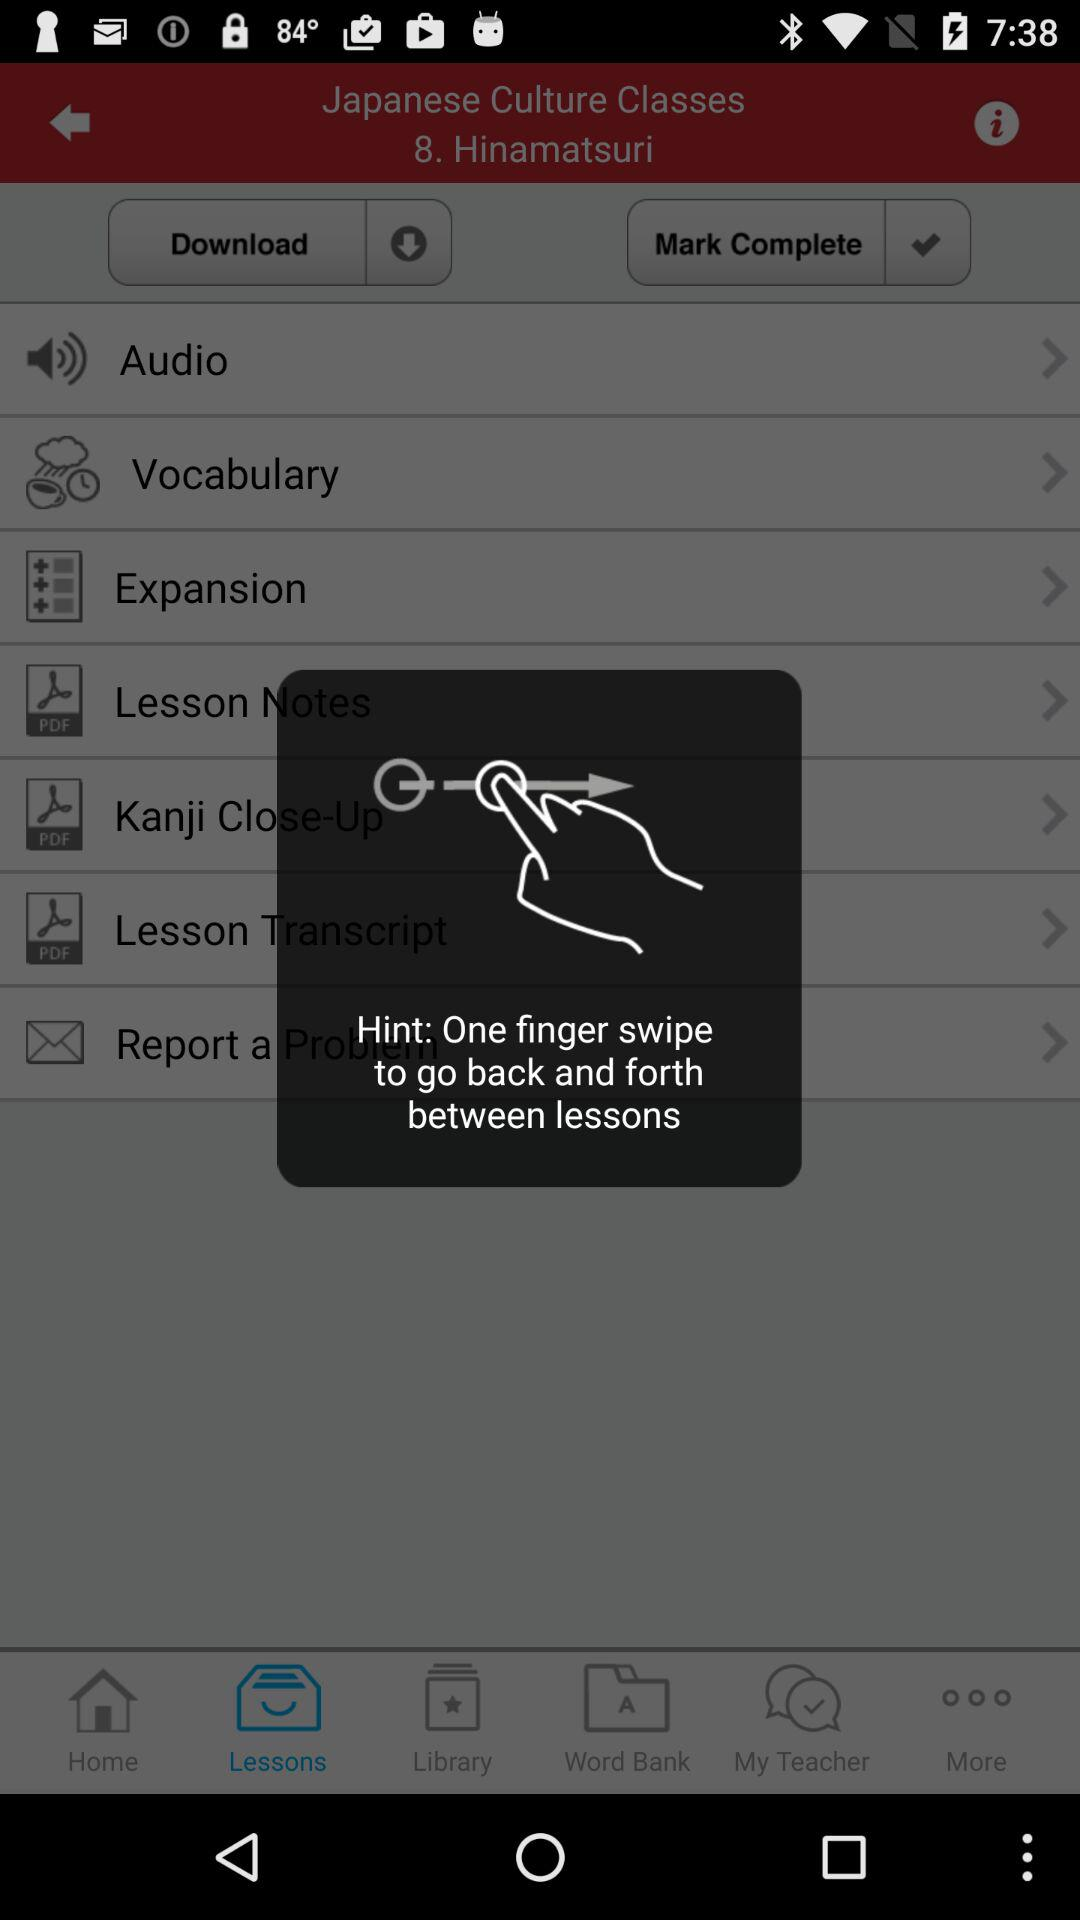What should be done to go back and forth between lessons? To go back and forth between lessons, one finger swipe should be done. 